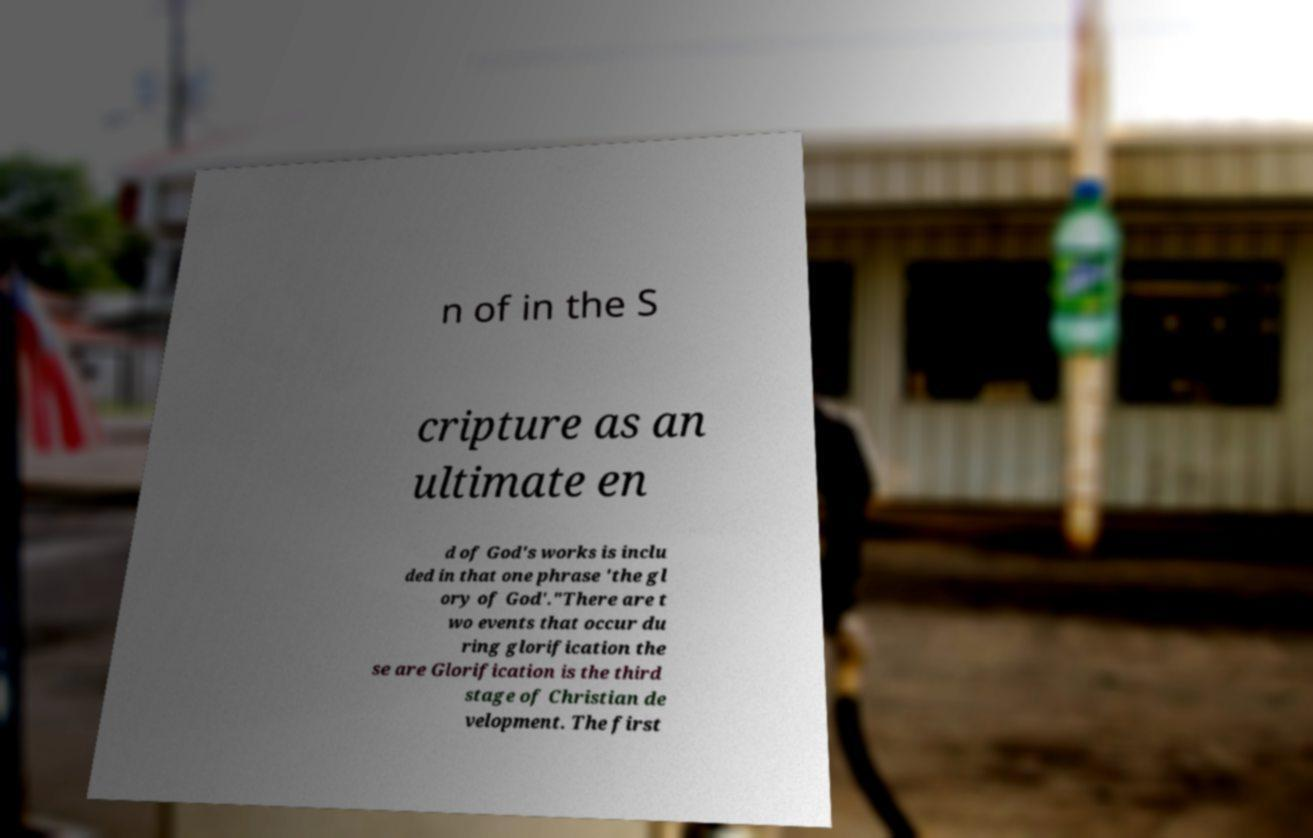Can you accurately transcribe the text from the provided image for me? n of in the S cripture as an ultimate en d of God's works is inclu ded in that one phrase 'the gl ory of God'."There are t wo events that occur du ring glorification the se are Glorification is the third stage of Christian de velopment. The first 